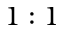<formula> <loc_0><loc_0><loc_500><loc_500>1 \colon 1</formula> 